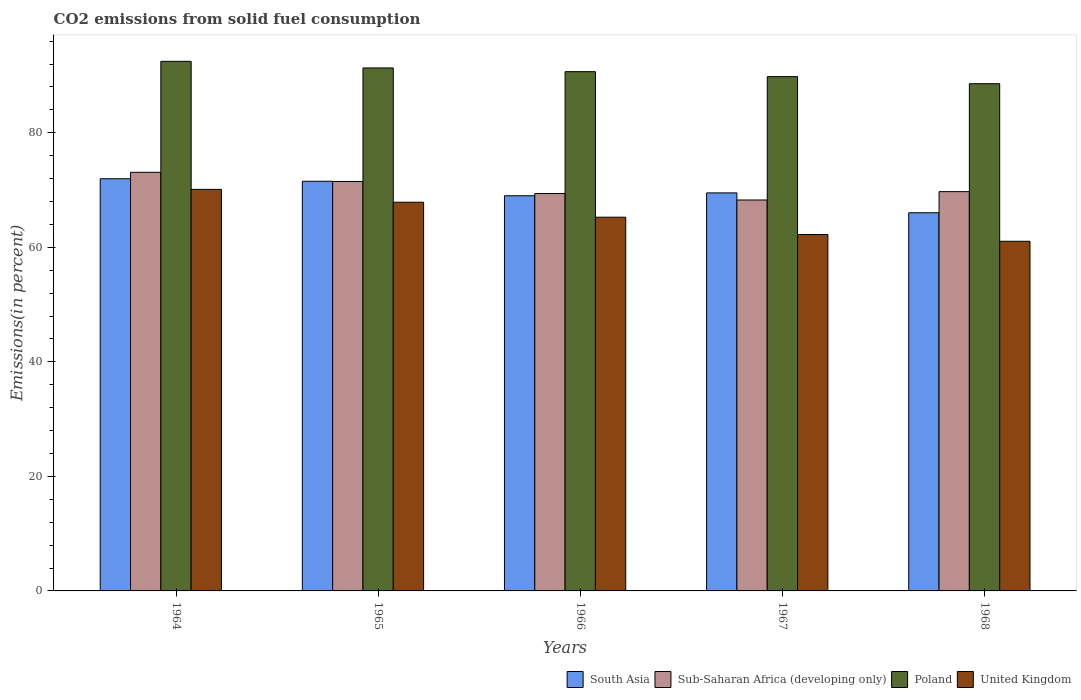How many different coloured bars are there?
Give a very brief answer. 4. How many groups of bars are there?
Your response must be concise. 5. Are the number of bars per tick equal to the number of legend labels?
Your answer should be very brief. Yes. Are the number of bars on each tick of the X-axis equal?
Offer a terse response. Yes. How many bars are there on the 3rd tick from the left?
Keep it short and to the point. 4. What is the label of the 4th group of bars from the left?
Provide a succinct answer. 1967. In how many cases, is the number of bars for a given year not equal to the number of legend labels?
Your response must be concise. 0. What is the total CO2 emitted in Poland in 1967?
Your answer should be compact. 89.81. Across all years, what is the maximum total CO2 emitted in Poland?
Ensure brevity in your answer.  92.48. Across all years, what is the minimum total CO2 emitted in United Kingdom?
Make the answer very short. 61.06. In which year was the total CO2 emitted in South Asia maximum?
Offer a terse response. 1964. In which year was the total CO2 emitted in Poland minimum?
Offer a terse response. 1968. What is the total total CO2 emitted in South Asia in the graph?
Your response must be concise. 348.07. What is the difference between the total CO2 emitted in Sub-Saharan Africa (developing only) in 1965 and that in 1967?
Your answer should be compact. 3.24. What is the difference between the total CO2 emitted in South Asia in 1968 and the total CO2 emitted in Sub-Saharan Africa (developing only) in 1966?
Your answer should be compact. -3.36. What is the average total CO2 emitted in South Asia per year?
Keep it short and to the point. 69.61. In the year 1964, what is the difference between the total CO2 emitted in Sub-Saharan Africa (developing only) and total CO2 emitted in South Asia?
Give a very brief answer. 1.12. What is the ratio of the total CO2 emitted in United Kingdom in 1964 to that in 1968?
Offer a terse response. 1.15. Is the total CO2 emitted in South Asia in 1967 less than that in 1968?
Ensure brevity in your answer.  No. Is the difference between the total CO2 emitted in Sub-Saharan Africa (developing only) in 1965 and 1967 greater than the difference between the total CO2 emitted in South Asia in 1965 and 1967?
Your answer should be very brief. Yes. What is the difference between the highest and the second highest total CO2 emitted in United Kingdom?
Your answer should be very brief. 2.24. What is the difference between the highest and the lowest total CO2 emitted in Poland?
Keep it short and to the point. 3.9. In how many years, is the total CO2 emitted in Sub-Saharan Africa (developing only) greater than the average total CO2 emitted in Sub-Saharan Africa (developing only) taken over all years?
Your answer should be compact. 2. Is it the case that in every year, the sum of the total CO2 emitted in Poland and total CO2 emitted in South Asia is greater than the sum of total CO2 emitted in United Kingdom and total CO2 emitted in Sub-Saharan Africa (developing only)?
Give a very brief answer. Yes. What does the 1st bar from the left in 1968 represents?
Your response must be concise. South Asia. What does the 2nd bar from the right in 1966 represents?
Ensure brevity in your answer.  Poland. Is it the case that in every year, the sum of the total CO2 emitted in South Asia and total CO2 emitted in United Kingdom is greater than the total CO2 emitted in Poland?
Your answer should be compact. Yes. How many bars are there?
Offer a very short reply. 20. What is the difference between two consecutive major ticks on the Y-axis?
Give a very brief answer. 20. How are the legend labels stacked?
Offer a terse response. Horizontal. What is the title of the graph?
Your answer should be compact. CO2 emissions from solid fuel consumption. What is the label or title of the X-axis?
Provide a succinct answer. Years. What is the label or title of the Y-axis?
Your answer should be compact. Emissions(in percent). What is the Emissions(in percent) of South Asia in 1964?
Provide a succinct answer. 71.98. What is the Emissions(in percent) in Sub-Saharan Africa (developing only) in 1964?
Give a very brief answer. 73.1. What is the Emissions(in percent) of Poland in 1964?
Provide a succinct answer. 92.48. What is the Emissions(in percent) of United Kingdom in 1964?
Your answer should be very brief. 70.12. What is the Emissions(in percent) in South Asia in 1965?
Provide a short and direct response. 71.54. What is the Emissions(in percent) of Sub-Saharan Africa (developing only) in 1965?
Keep it short and to the point. 71.5. What is the Emissions(in percent) of Poland in 1965?
Give a very brief answer. 91.33. What is the Emissions(in percent) in United Kingdom in 1965?
Ensure brevity in your answer.  67.88. What is the Emissions(in percent) in South Asia in 1966?
Provide a short and direct response. 69.01. What is the Emissions(in percent) in Sub-Saharan Africa (developing only) in 1966?
Ensure brevity in your answer.  69.39. What is the Emissions(in percent) in Poland in 1966?
Keep it short and to the point. 90.68. What is the Emissions(in percent) in United Kingdom in 1966?
Your response must be concise. 65.26. What is the Emissions(in percent) of South Asia in 1967?
Your answer should be compact. 69.51. What is the Emissions(in percent) in Sub-Saharan Africa (developing only) in 1967?
Your answer should be compact. 68.27. What is the Emissions(in percent) of Poland in 1967?
Your answer should be very brief. 89.81. What is the Emissions(in percent) in United Kingdom in 1967?
Your answer should be compact. 62.24. What is the Emissions(in percent) in South Asia in 1968?
Your answer should be compact. 66.04. What is the Emissions(in percent) in Sub-Saharan Africa (developing only) in 1968?
Keep it short and to the point. 69.73. What is the Emissions(in percent) in Poland in 1968?
Offer a very short reply. 88.58. What is the Emissions(in percent) in United Kingdom in 1968?
Keep it short and to the point. 61.06. Across all years, what is the maximum Emissions(in percent) in South Asia?
Offer a terse response. 71.98. Across all years, what is the maximum Emissions(in percent) in Sub-Saharan Africa (developing only)?
Your answer should be very brief. 73.1. Across all years, what is the maximum Emissions(in percent) in Poland?
Your answer should be compact. 92.48. Across all years, what is the maximum Emissions(in percent) of United Kingdom?
Give a very brief answer. 70.12. Across all years, what is the minimum Emissions(in percent) in South Asia?
Give a very brief answer. 66.04. Across all years, what is the minimum Emissions(in percent) in Sub-Saharan Africa (developing only)?
Provide a succinct answer. 68.27. Across all years, what is the minimum Emissions(in percent) of Poland?
Your answer should be compact. 88.58. Across all years, what is the minimum Emissions(in percent) in United Kingdom?
Offer a terse response. 61.06. What is the total Emissions(in percent) of South Asia in the graph?
Provide a short and direct response. 348.07. What is the total Emissions(in percent) of Sub-Saharan Africa (developing only) in the graph?
Make the answer very short. 351.99. What is the total Emissions(in percent) of Poland in the graph?
Offer a terse response. 452.86. What is the total Emissions(in percent) in United Kingdom in the graph?
Make the answer very short. 326.56. What is the difference between the Emissions(in percent) of South Asia in 1964 and that in 1965?
Your answer should be very brief. 0.44. What is the difference between the Emissions(in percent) in Sub-Saharan Africa (developing only) in 1964 and that in 1965?
Provide a short and direct response. 1.6. What is the difference between the Emissions(in percent) of Poland in 1964 and that in 1965?
Ensure brevity in your answer.  1.15. What is the difference between the Emissions(in percent) of United Kingdom in 1964 and that in 1965?
Provide a succinct answer. 2.25. What is the difference between the Emissions(in percent) of South Asia in 1964 and that in 1966?
Give a very brief answer. 2.97. What is the difference between the Emissions(in percent) of Sub-Saharan Africa (developing only) in 1964 and that in 1966?
Make the answer very short. 3.71. What is the difference between the Emissions(in percent) of Poland in 1964 and that in 1966?
Ensure brevity in your answer.  1.8. What is the difference between the Emissions(in percent) of United Kingdom in 1964 and that in 1966?
Give a very brief answer. 4.86. What is the difference between the Emissions(in percent) of South Asia in 1964 and that in 1967?
Keep it short and to the point. 2.47. What is the difference between the Emissions(in percent) in Sub-Saharan Africa (developing only) in 1964 and that in 1967?
Offer a very short reply. 4.83. What is the difference between the Emissions(in percent) in Poland in 1964 and that in 1967?
Offer a very short reply. 2.67. What is the difference between the Emissions(in percent) in United Kingdom in 1964 and that in 1967?
Your answer should be compact. 7.88. What is the difference between the Emissions(in percent) of South Asia in 1964 and that in 1968?
Make the answer very short. 5.94. What is the difference between the Emissions(in percent) in Sub-Saharan Africa (developing only) in 1964 and that in 1968?
Offer a very short reply. 3.38. What is the difference between the Emissions(in percent) of Poland in 1964 and that in 1968?
Your answer should be compact. 3.9. What is the difference between the Emissions(in percent) of United Kingdom in 1964 and that in 1968?
Your answer should be very brief. 9.06. What is the difference between the Emissions(in percent) in South Asia in 1965 and that in 1966?
Give a very brief answer. 2.53. What is the difference between the Emissions(in percent) of Sub-Saharan Africa (developing only) in 1965 and that in 1966?
Keep it short and to the point. 2.11. What is the difference between the Emissions(in percent) in Poland in 1965 and that in 1966?
Your answer should be compact. 0.65. What is the difference between the Emissions(in percent) of United Kingdom in 1965 and that in 1966?
Give a very brief answer. 2.62. What is the difference between the Emissions(in percent) of South Asia in 1965 and that in 1967?
Make the answer very short. 2.03. What is the difference between the Emissions(in percent) of Sub-Saharan Africa (developing only) in 1965 and that in 1967?
Make the answer very short. 3.24. What is the difference between the Emissions(in percent) in Poland in 1965 and that in 1967?
Your answer should be compact. 1.52. What is the difference between the Emissions(in percent) of United Kingdom in 1965 and that in 1967?
Your response must be concise. 5.64. What is the difference between the Emissions(in percent) in South Asia in 1965 and that in 1968?
Give a very brief answer. 5.5. What is the difference between the Emissions(in percent) in Sub-Saharan Africa (developing only) in 1965 and that in 1968?
Your answer should be compact. 1.78. What is the difference between the Emissions(in percent) in Poland in 1965 and that in 1968?
Offer a terse response. 2.75. What is the difference between the Emissions(in percent) in United Kingdom in 1965 and that in 1968?
Offer a terse response. 6.82. What is the difference between the Emissions(in percent) of South Asia in 1966 and that in 1967?
Provide a short and direct response. -0.5. What is the difference between the Emissions(in percent) in Sub-Saharan Africa (developing only) in 1966 and that in 1967?
Keep it short and to the point. 1.13. What is the difference between the Emissions(in percent) of Poland in 1966 and that in 1967?
Offer a very short reply. 0.87. What is the difference between the Emissions(in percent) in United Kingdom in 1966 and that in 1967?
Give a very brief answer. 3.02. What is the difference between the Emissions(in percent) of South Asia in 1966 and that in 1968?
Keep it short and to the point. 2.97. What is the difference between the Emissions(in percent) of Sub-Saharan Africa (developing only) in 1966 and that in 1968?
Your response must be concise. -0.33. What is the difference between the Emissions(in percent) in Poland in 1966 and that in 1968?
Your response must be concise. 2.1. What is the difference between the Emissions(in percent) in United Kingdom in 1966 and that in 1968?
Ensure brevity in your answer.  4.2. What is the difference between the Emissions(in percent) in South Asia in 1967 and that in 1968?
Keep it short and to the point. 3.47. What is the difference between the Emissions(in percent) in Sub-Saharan Africa (developing only) in 1967 and that in 1968?
Provide a succinct answer. -1.46. What is the difference between the Emissions(in percent) in Poland in 1967 and that in 1968?
Keep it short and to the point. 1.23. What is the difference between the Emissions(in percent) of United Kingdom in 1967 and that in 1968?
Your answer should be compact. 1.18. What is the difference between the Emissions(in percent) of South Asia in 1964 and the Emissions(in percent) of Sub-Saharan Africa (developing only) in 1965?
Provide a succinct answer. 0.48. What is the difference between the Emissions(in percent) of South Asia in 1964 and the Emissions(in percent) of Poland in 1965?
Give a very brief answer. -19.35. What is the difference between the Emissions(in percent) in South Asia in 1964 and the Emissions(in percent) in United Kingdom in 1965?
Your answer should be very brief. 4.1. What is the difference between the Emissions(in percent) in Sub-Saharan Africa (developing only) in 1964 and the Emissions(in percent) in Poland in 1965?
Offer a terse response. -18.22. What is the difference between the Emissions(in percent) in Sub-Saharan Africa (developing only) in 1964 and the Emissions(in percent) in United Kingdom in 1965?
Offer a terse response. 5.23. What is the difference between the Emissions(in percent) of Poland in 1964 and the Emissions(in percent) of United Kingdom in 1965?
Provide a short and direct response. 24.6. What is the difference between the Emissions(in percent) in South Asia in 1964 and the Emissions(in percent) in Sub-Saharan Africa (developing only) in 1966?
Ensure brevity in your answer.  2.59. What is the difference between the Emissions(in percent) in South Asia in 1964 and the Emissions(in percent) in Poland in 1966?
Your answer should be very brief. -18.7. What is the difference between the Emissions(in percent) of South Asia in 1964 and the Emissions(in percent) of United Kingdom in 1966?
Make the answer very short. 6.72. What is the difference between the Emissions(in percent) in Sub-Saharan Africa (developing only) in 1964 and the Emissions(in percent) in Poland in 1966?
Your answer should be compact. -17.58. What is the difference between the Emissions(in percent) in Sub-Saharan Africa (developing only) in 1964 and the Emissions(in percent) in United Kingdom in 1966?
Your answer should be very brief. 7.84. What is the difference between the Emissions(in percent) in Poland in 1964 and the Emissions(in percent) in United Kingdom in 1966?
Provide a succinct answer. 27.22. What is the difference between the Emissions(in percent) of South Asia in 1964 and the Emissions(in percent) of Sub-Saharan Africa (developing only) in 1967?
Your answer should be very brief. 3.71. What is the difference between the Emissions(in percent) in South Asia in 1964 and the Emissions(in percent) in Poland in 1967?
Your answer should be very brief. -17.83. What is the difference between the Emissions(in percent) in South Asia in 1964 and the Emissions(in percent) in United Kingdom in 1967?
Provide a succinct answer. 9.74. What is the difference between the Emissions(in percent) in Sub-Saharan Africa (developing only) in 1964 and the Emissions(in percent) in Poland in 1967?
Ensure brevity in your answer.  -16.71. What is the difference between the Emissions(in percent) in Sub-Saharan Africa (developing only) in 1964 and the Emissions(in percent) in United Kingdom in 1967?
Offer a very short reply. 10.86. What is the difference between the Emissions(in percent) of Poland in 1964 and the Emissions(in percent) of United Kingdom in 1967?
Make the answer very short. 30.24. What is the difference between the Emissions(in percent) in South Asia in 1964 and the Emissions(in percent) in Sub-Saharan Africa (developing only) in 1968?
Offer a terse response. 2.25. What is the difference between the Emissions(in percent) of South Asia in 1964 and the Emissions(in percent) of Poland in 1968?
Make the answer very short. -16.6. What is the difference between the Emissions(in percent) in South Asia in 1964 and the Emissions(in percent) in United Kingdom in 1968?
Give a very brief answer. 10.92. What is the difference between the Emissions(in percent) in Sub-Saharan Africa (developing only) in 1964 and the Emissions(in percent) in Poland in 1968?
Offer a very short reply. -15.47. What is the difference between the Emissions(in percent) of Sub-Saharan Africa (developing only) in 1964 and the Emissions(in percent) of United Kingdom in 1968?
Offer a very short reply. 12.04. What is the difference between the Emissions(in percent) of Poland in 1964 and the Emissions(in percent) of United Kingdom in 1968?
Give a very brief answer. 31.42. What is the difference between the Emissions(in percent) in South Asia in 1965 and the Emissions(in percent) in Sub-Saharan Africa (developing only) in 1966?
Give a very brief answer. 2.14. What is the difference between the Emissions(in percent) in South Asia in 1965 and the Emissions(in percent) in Poland in 1966?
Make the answer very short. -19.14. What is the difference between the Emissions(in percent) in South Asia in 1965 and the Emissions(in percent) in United Kingdom in 1966?
Offer a terse response. 6.28. What is the difference between the Emissions(in percent) of Sub-Saharan Africa (developing only) in 1965 and the Emissions(in percent) of Poland in 1966?
Offer a very short reply. -19.18. What is the difference between the Emissions(in percent) of Sub-Saharan Africa (developing only) in 1965 and the Emissions(in percent) of United Kingdom in 1966?
Offer a very short reply. 6.24. What is the difference between the Emissions(in percent) of Poland in 1965 and the Emissions(in percent) of United Kingdom in 1966?
Provide a succinct answer. 26.07. What is the difference between the Emissions(in percent) of South Asia in 1965 and the Emissions(in percent) of Sub-Saharan Africa (developing only) in 1967?
Your answer should be compact. 3.27. What is the difference between the Emissions(in percent) of South Asia in 1965 and the Emissions(in percent) of Poland in 1967?
Your answer should be compact. -18.27. What is the difference between the Emissions(in percent) of South Asia in 1965 and the Emissions(in percent) of United Kingdom in 1967?
Your response must be concise. 9.3. What is the difference between the Emissions(in percent) in Sub-Saharan Africa (developing only) in 1965 and the Emissions(in percent) in Poland in 1967?
Offer a very short reply. -18.31. What is the difference between the Emissions(in percent) of Sub-Saharan Africa (developing only) in 1965 and the Emissions(in percent) of United Kingdom in 1967?
Offer a terse response. 9.26. What is the difference between the Emissions(in percent) in Poland in 1965 and the Emissions(in percent) in United Kingdom in 1967?
Keep it short and to the point. 29.09. What is the difference between the Emissions(in percent) in South Asia in 1965 and the Emissions(in percent) in Sub-Saharan Africa (developing only) in 1968?
Ensure brevity in your answer.  1.81. What is the difference between the Emissions(in percent) of South Asia in 1965 and the Emissions(in percent) of Poland in 1968?
Offer a very short reply. -17.04. What is the difference between the Emissions(in percent) in South Asia in 1965 and the Emissions(in percent) in United Kingdom in 1968?
Offer a very short reply. 10.48. What is the difference between the Emissions(in percent) of Sub-Saharan Africa (developing only) in 1965 and the Emissions(in percent) of Poland in 1968?
Give a very brief answer. -17.07. What is the difference between the Emissions(in percent) in Sub-Saharan Africa (developing only) in 1965 and the Emissions(in percent) in United Kingdom in 1968?
Keep it short and to the point. 10.44. What is the difference between the Emissions(in percent) of Poland in 1965 and the Emissions(in percent) of United Kingdom in 1968?
Your response must be concise. 30.27. What is the difference between the Emissions(in percent) in South Asia in 1966 and the Emissions(in percent) in Sub-Saharan Africa (developing only) in 1967?
Make the answer very short. 0.74. What is the difference between the Emissions(in percent) in South Asia in 1966 and the Emissions(in percent) in Poland in 1967?
Your response must be concise. -20.8. What is the difference between the Emissions(in percent) in South Asia in 1966 and the Emissions(in percent) in United Kingdom in 1967?
Make the answer very short. 6.77. What is the difference between the Emissions(in percent) of Sub-Saharan Africa (developing only) in 1966 and the Emissions(in percent) of Poland in 1967?
Keep it short and to the point. -20.41. What is the difference between the Emissions(in percent) in Sub-Saharan Africa (developing only) in 1966 and the Emissions(in percent) in United Kingdom in 1967?
Give a very brief answer. 7.15. What is the difference between the Emissions(in percent) in Poland in 1966 and the Emissions(in percent) in United Kingdom in 1967?
Give a very brief answer. 28.44. What is the difference between the Emissions(in percent) in South Asia in 1966 and the Emissions(in percent) in Sub-Saharan Africa (developing only) in 1968?
Offer a terse response. -0.72. What is the difference between the Emissions(in percent) in South Asia in 1966 and the Emissions(in percent) in Poland in 1968?
Offer a very short reply. -19.57. What is the difference between the Emissions(in percent) of South Asia in 1966 and the Emissions(in percent) of United Kingdom in 1968?
Make the answer very short. 7.95. What is the difference between the Emissions(in percent) of Sub-Saharan Africa (developing only) in 1966 and the Emissions(in percent) of Poland in 1968?
Provide a succinct answer. -19.18. What is the difference between the Emissions(in percent) in Sub-Saharan Africa (developing only) in 1966 and the Emissions(in percent) in United Kingdom in 1968?
Offer a terse response. 8.34. What is the difference between the Emissions(in percent) of Poland in 1966 and the Emissions(in percent) of United Kingdom in 1968?
Give a very brief answer. 29.62. What is the difference between the Emissions(in percent) of South Asia in 1967 and the Emissions(in percent) of Sub-Saharan Africa (developing only) in 1968?
Your response must be concise. -0.22. What is the difference between the Emissions(in percent) in South Asia in 1967 and the Emissions(in percent) in Poland in 1968?
Offer a very short reply. -19.07. What is the difference between the Emissions(in percent) of South Asia in 1967 and the Emissions(in percent) of United Kingdom in 1968?
Keep it short and to the point. 8.45. What is the difference between the Emissions(in percent) in Sub-Saharan Africa (developing only) in 1967 and the Emissions(in percent) in Poland in 1968?
Offer a very short reply. -20.31. What is the difference between the Emissions(in percent) in Sub-Saharan Africa (developing only) in 1967 and the Emissions(in percent) in United Kingdom in 1968?
Offer a terse response. 7.21. What is the difference between the Emissions(in percent) in Poland in 1967 and the Emissions(in percent) in United Kingdom in 1968?
Your answer should be very brief. 28.75. What is the average Emissions(in percent) in South Asia per year?
Your response must be concise. 69.61. What is the average Emissions(in percent) in Sub-Saharan Africa (developing only) per year?
Give a very brief answer. 70.4. What is the average Emissions(in percent) of Poland per year?
Give a very brief answer. 90.57. What is the average Emissions(in percent) in United Kingdom per year?
Keep it short and to the point. 65.31. In the year 1964, what is the difference between the Emissions(in percent) of South Asia and Emissions(in percent) of Sub-Saharan Africa (developing only)?
Ensure brevity in your answer.  -1.12. In the year 1964, what is the difference between the Emissions(in percent) in South Asia and Emissions(in percent) in Poland?
Keep it short and to the point. -20.5. In the year 1964, what is the difference between the Emissions(in percent) in South Asia and Emissions(in percent) in United Kingdom?
Offer a terse response. 1.86. In the year 1964, what is the difference between the Emissions(in percent) in Sub-Saharan Africa (developing only) and Emissions(in percent) in Poland?
Offer a terse response. -19.37. In the year 1964, what is the difference between the Emissions(in percent) in Sub-Saharan Africa (developing only) and Emissions(in percent) in United Kingdom?
Keep it short and to the point. 2.98. In the year 1964, what is the difference between the Emissions(in percent) of Poland and Emissions(in percent) of United Kingdom?
Your answer should be compact. 22.35. In the year 1965, what is the difference between the Emissions(in percent) in South Asia and Emissions(in percent) in Sub-Saharan Africa (developing only)?
Ensure brevity in your answer.  0.04. In the year 1965, what is the difference between the Emissions(in percent) of South Asia and Emissions(in percent) of Poland?
Provide a succinct answer. -19.79. In the year 1965, what is the difference between the Emissions(in percent) in South Asia and Emissions(in percent) in United Kingdom?
Your response must be concise. 3.66. In the year 1965, what is the difference between the Emissions(in percent) of Sub-Saharan Africa (developing only) and Emissions(in percent) of Poland?
Your response must be concise. -19.82. In the year 1965, what is the difference between the Emissions(in percent) in Sub-Saharan Africa (developing only) and Emissions(in percent) in United Kingdom?
Offer a terse response. 3.63. In the year 1965, what is the difference between the Emissions(in percent) in Poland and Emissions(in percent) in United Kingdom?
Offer a terse response. 23.45. In the year 1966, what is the difference between the Emissions(in percent) in South Asia and Emissions(in percent) in Sub-Saharan Africa (developing only)?
Make the answer very short. -0.39. In the year 1966, what is the difference between the Emissions(in percent) in South Asia and Emissions(in percent) in Poland?
Your answer should be very brief. -21.67. In the year 1966, what is the difference between the Emissions(in percent) of South Asia and Emissions(in percent) of United Kingdom?
Provide a succinct answer. 3.75. In the year 1966, what is the difference between the Emissions(in percent) in Sub-Saharan Africa (developing only) and Emissions(in percent) in Poland?
Offer a terse response. -21.28. In the year 1966, what is the difference between the Emissions(in percent) of Sub-Saharan Africa (developing only) and Emissions(in percent) of United Kingdom?
Make the answer very short. 4.13. In the year 1966, what is the difference between the Emissions(in percent) in Poland and Emissions(in percent) in United Kingdom?
Your answer should be compact. 25.42. In the year 1967, what is the difference between the Emissions(in percent) of South Asia and Emissions(in percent) of Sub-Saharan Africa (developing only)?
Offer a terse response. 1.24. In the year 1967, what is the difference between the Emissions(in percent) of South Asia and Emissions(in percent) of Poland?
Offer a terse response. -20.3. In the year 1967, what is the difference between the Emissions(in percent) in South Asia and Emissions(in percent) in United Kingdom?
Your response must be concise. 7.27. In the year 1967, what is the difference between the Emissions(in percent) in Sub-Saharan Africa (developing only) and Emissions(in percent) in Poland?
Offer a terse response. -21.54. In the year 1967, what is the difference between the Emissions(in percent) in Sub-Saharan Africa (developing only) and Emissions(in percent) in United Kingdom?
Your answer should be very brief. 6.03. In the year 1967, what is the difference between the Emissions(in percent) of Poland and Emissions(in percent) of United Kingdom?
Keep it short and to the point. 27.57. In the year 1968, what is the difference between the Emissions(in percent) of South Asia and Emissions(in percent) of Sub-Saharan Africa (developing only)?
Your response must be concise. -3.69. In the year 1968, what is the difference between the Emissions(in percent) of South Asia and Emissions(in percent) of Poland?
Offer a terse response. -22.54. In the year 1968, what is the difference between the Emissions(in percent) of South Asia and Emissions(in percent) of United Kingdom?
Your answer should be very brief. 4.98. In the year 1968, what is the difference between the Emissions(in percent) of Sub-Saharan Africa (developing only) and Emissions(in percent) of Poland?
Keep it short and to the point. -18.85. In the year 1968, what is the difference between the Emissions(in percent) of Sub-Saharan Africa (developing only) and Emissions(in percent) of United Kingdom?
Your response must be concise. 8.67. In the year 1968, what is the difference between the Emissions(in percent) of Poland and Emissions(in percent) of United Kingdom?
Offer a terse response. 27.52. What is the ratio of the Emissions(in percent) of Sub-Saharan Africa (developing only) in 1964 to that in 1965?
Give a very brief answer. 1.02. What is the ratio of the Emissions(in percent) in Poland in 1964 to that in 1965?
Your answer should be very brief. 1.01. What is the ratio of the Emissions(in percent) in United Kingdom in 1964 to that in 1965?
Make the answer very short. 1.03. What is the ratio of the Emissions(in percent) of South Asia in 1964 to that in 1966?
Your answer should be very brief. 1.04. What is the ratio of the Emissions(in percent) in Sub-Saharan Africa (developing only) in 1964 to that in 1966?
Make the answer very short. 1.05. What is the ratio of the Emissions(in percent) of Poland in 1964 to that in 1966?
Offer a terse response. 1.02. What is the ratio of the Emissions(in percent) of United Kingdom in 1964 to that in 1966?
Keep it short and to the point. 1.07. What is the ratio of the Emissions(in percent) of South Asia in 1964 to that in 1967?
Your answer should be compact. 1.04. What is the ratio of the Emissions(in percent) in Sub-Saharan Africa (developing only) in 1964 to that in 1967?
Provide a succinct answer. 1.07. What is the ratio of the Emissions(in percent) in Poland in 1964 to that in 1967?
Your answer should be very brief. 1.03. What is the ratio of the Emissions(in percent) in United Kingdom in 1964 to that in 1967?
Your response must be concise. 1.13. What is the ratio of the Emissions(in percent) in South Asia in 1964 to that in 1968?
Keep it short and to the point. 1.09. What is the ratio of the Emissions(in percent) in Sub-Saharan Africa (developing only) in 1964 to that in 1968?
Offer a terse response. 1.05. What is the ratio of the Emissions(in percent) in Poland in 1964 to that in 1968?
Offer a terse response. 1.04. What is the ratio of the Emissions(in percent) of United Kingdom in 1964 to that in 1968?
Give a very brief answer. 1.15. What is the ratio of the Emissions(in percent) in South Asia in 1965 to that in 1966?
Provide a short and direct response. 1.04. What is the ratio of the Emissions(in percent) in Sub-Saharan Africa (developing only) in 1965 to that in 1966?
Your answer should be compact. 1.03. What is the ratio of the Emissions(in percent) of United Kingdom in 1965 to that in 1966?
Make the answer very short. 1.04. What is the ratio of the Emissions(in percent) of South Asia in 1965 to that in 1967?
Your answer should be very brief. 1.03. What is the ratio of the Emissions(in percent) of Sub-Saharan Africa (developing only) in 1965 to that in 1967?
Make the answer very short. 1.05. What is the ratio of the Emissions(in percent) of Poland in 1965 to that in 1967?
Give a very brief answer. 1.02. What is the ratio of the Emissions(in percent) in United Kingdom in 1965 to that in 1967?
Keep it short and to the point. 1.09. What is the ratio of the Emissions(in percent) in South Asia in 1965 to that in 1968?
Make the answer very short. 1.08. What is the ratio of the Emissions(in percent) in Sub-Saharan Africa (developing only) in 1965 to that in 1968?
Offer a very short reply. 1.03. What is the ratio of the Emissions(in percent) in Poland in 1965 to that in 1968?
Offer a terse response. 1.03. What is the ratio of the Emissions(in percent) of United Kingdom in 1965 to that in 1968?
Make the answer very short. 1.11. What is the ratio of the Emissions(in percent) in Sub-Saharan Africa (developing only) in 1966 to that in 1967?
Keep it short and to the point. 1.02. What is the ratio of the Emissions(in percent) of Poland in 1966 to that in 1967?
Ensure brevity in your answer.  1.01. What is the ratio of the Emissions(in percent) of United Kingdom in 1966 to that in 1967?
Your answer should be compact. 1.05. What is the ratio of the Emissions(in percent) in South Asia in 1966 to that in 1968?
Give a very brief answer. 1.04. What is the ratio of the Emissions(in percent) in Poland in 1966 to that in 1968?
Keep it short and to the point. 1.02. What is the ratio of the Emissions(in percent) of United Kingdom in 1966 to that in 1968?
Your response must be concise. 1.07. What is the ratio of the Emissions(in percent) of South Asia in 1967 to that in 1968?
Provide a succinct answer. 1.05. What is the ratio of the Emissions(in percent) of Sub-Saharan Africa (developing only) in 1967 to that in 1968?
Give a very brief answer. 0.98. What is the ratio of the Emissions(in percent) in Poland in 1967 to that in 1968?
Provide a short and direct response. 1.01. What is the ratio of the Emissions(in percent) of United Kingdom in 1967 to that in 1968?
Provide a short and direct response. 1.02. What is the difference between the highest and the second highest Emissions(in percent) of South Asia?
Make the answer very short. 0.44. What is the difference between the highest and the second highest Emissions(in percent) in Sub-Saharan Africa (developing only)?
Your response must be concise. 1.6. What is the difference between the highest and the second highest Emissions(in percent) of Poland?
Your answer should be compact. 1.15. What is the difference between the highest and the second highest Emissions(in percent) of United Kingdom?
Provide a short and direct response. 2.25. What is the difference between the highest and the lowest Emissions(in percent) in South Asia?
Ensure brevity in your answer.  5.94. What is the difference between the highest and the lowest Emissions(in percent) in Sub-Saharan Africa (developing only)?
Keep it short and to the point. 4.83. What is the difference between the highest and the lowest Emissions(in percent) in Poland?
Offer a very short reply. 3.9. What is the difference between the highest and the lowest Emissions(in percent) of United Kingdom?
Keep it short and to the point. 9.06. 